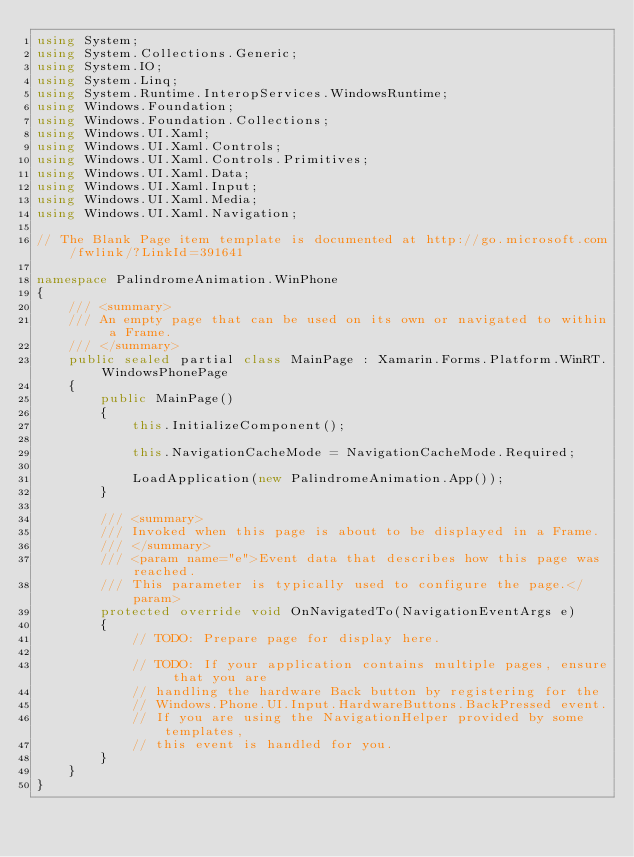<code> <loc_0><loc_0><loc_500><loc_500><_C#_>using System;
using System.Collections.Generic;
using System.IO;
using System.Linq;
using System.Runtime.InteropServices.WindowsRuntime;
using Windows.Foundation;
using Windows.Foundation.Collections;
using Windows.UI.Xaml;
using Windows.UI.Xaml.Controls;
using Windows.UI.Xaml.Controls.Primitives;
using Windows.UI.Xaml.Data;
using Windows.UI.Xaml.Input;
using Windows.UI.Xaml.Media;
using Windows.UI.Xaml.Navigation;

// The Blank Page item template is documented at http://go.microsoft.com/fwlink/?LinkId=391641

namespace PalindromeAnimation.WinPhone
{
    /// <summary>
    /// An empty page that can be used on its own or navigated to within a Frame.
    /// </summary>
    public sealed partial class MainPage : Xamarin.Forms.Platform.WinRT.WindowsPhonePage
    {
        public MainPage()
        {
            this.InitializeComponent();

            this.NavigationCacheMode = NavigationCacheMode.Required;

            LoadApplication(new PalindromeAnimation.App());
        }

        /// <summary>
        /// Invoked when this page is about to be displayed in a Frame.
        /// </summary>
        /// <param name="e">Event data that describes how this page was reached.
        /// This parameter is typically used to configure the page.</param>
        protected override void OnNavigatedTo(NavigationEventArgs e)
        {
            // TODO: Prepare page for display here.

            // TODO: If your application contains multiple pages, ensure that you are
            // handling the hardware Back button by registering for the
            // Windows.Phone.UI.Input.HardwareButtons.BackPressed event.
            // If you are using the NavigationHelper provided by some templates,
            // this event is handled for you.
        }
    }
}
</code> 